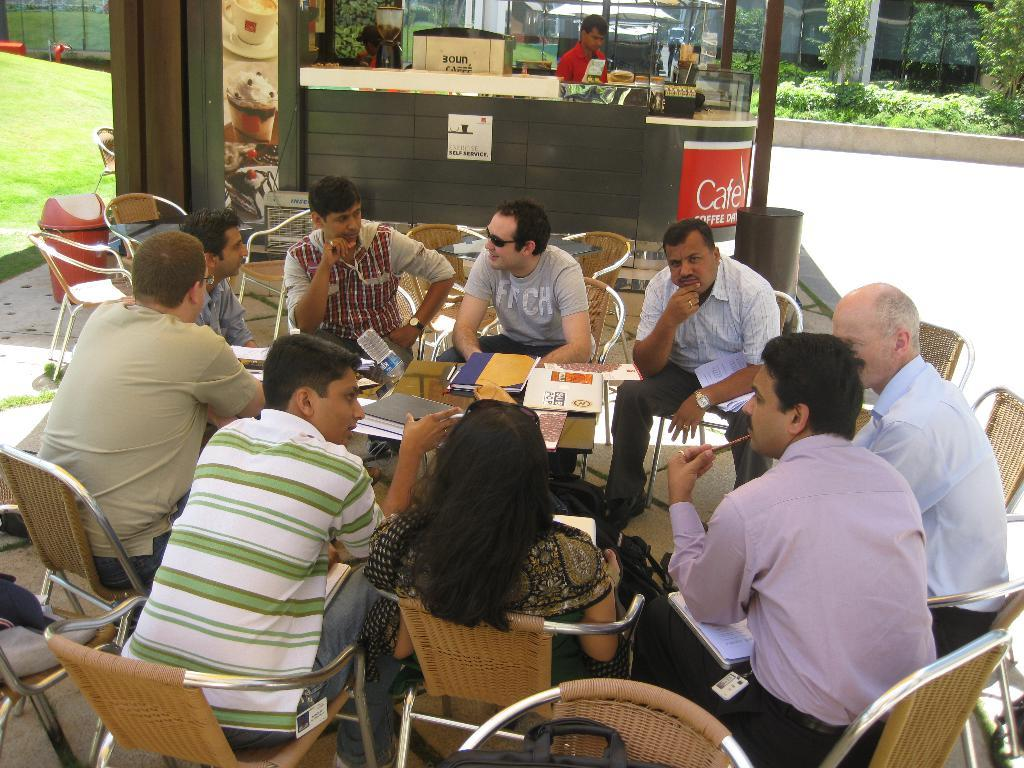What is happening in the image involving a group of people? There is a group of people in the image, and they are sitting on chairs. How are the chairs arranged in the image? The chairs are arranged around a table. What can be seen on the right side of the image? There are plants on the right side of the image. What type of coal is being used to form the table in the image? There is no coal present in the image, and the table is not formed from coal. 